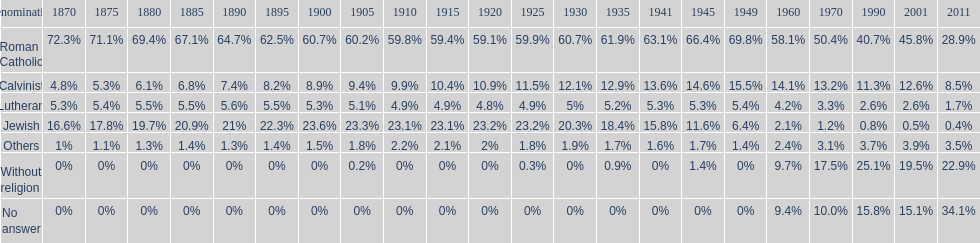Which denomination held the largest percentage in 1880? Roman Catholic. Can you parse all the data within this table? {'header': ['Denomination', '1870', '1875', '1880', '1885', '1890', '1895', '1900', '1905', '1910', '1915', '1920', '1925', '1930', '1935', '1941', '1945', '1949', '1960', '1970', '1990', '2001', '2011'], 'rows': [['Roman Catholic', '72.3%', '71.1%', '69.4%', '67.1%', '64.7%', '62.5%', '60.7%', '60.2%', '59.8%', '59.4%', '59.1%', '59.9%', '60.7%', '61.9%', '63.1%', '66.4%', '69.8%', '58.1%', '50.4%', '40.7%', '45.8%', '28.9%'], ['Calvinist', '4.8%', '5.3%', '6.1%', '6.8%', '7.4%', '8.2%', '8.9%', '9.4%', '9.9%', '10.4%', '10.9%', '11.5%', '12.1%', '12.9%', '13.6%', '14.6%', '15.5%', '14.1%', '13.2%', '11.3%', '12.6%', '8.5%'], ['Lutheran', '5.3%', '5.4%', '5.5%', '5.5%', '5.6%', '5.5%', '5.3%', '5.1%', '4.9%', '4.9%', '4.8%', '4.9%', '5%', '5.2%', '5.3%', '5.3%', '5.4%', '4.2%', '3.3%', '2.6%', '2.6%', '1.7%'], ['Jewish', '16.6%', '17.8%', '19.7%', '20.9%', '21%', '22.3%', '23.6%', '23.3%', '23.1%', '23.1%', '23.2%', '23.2%', '20.3%', '18.4%', '15.8%', '11.6%', '6.4%', '2.1%', '1.2%', '0.8%', '0.5%', '0.4%'], ['Others', '1%', '1.1%', '1.3%', '1.4%', '1.3%', '1.4%', '1.5%', '1.8%', '2.2%', '2.1%', '2%', '1.8%', '1.9%', '1.7%', '1.6%', '1.7%', '1.4%', '2.4%', '3.1%', '3.7%', '3.9%', '3.5%'], ['Without religion', '0%', '0%', '0%', '0%', '0%', '0%', '0%', '0.2%', '0%', '0%', '0%', '0.3%', '0%', '0.9%', '0%', '1.4%', '0%', '9.7%', '17.5%', '25.1%', '19.5%', '22.9%'], ['No answer', '0%', '0%', '0%', '0%', '0%', '0%', '0%', '0%', '0%', '0%', '0%', '0%', '0%', '0%', '0%', '0%', '0%', '9.4%', '10.0%', '15.8%', '15.1%', '34.1%']]} 